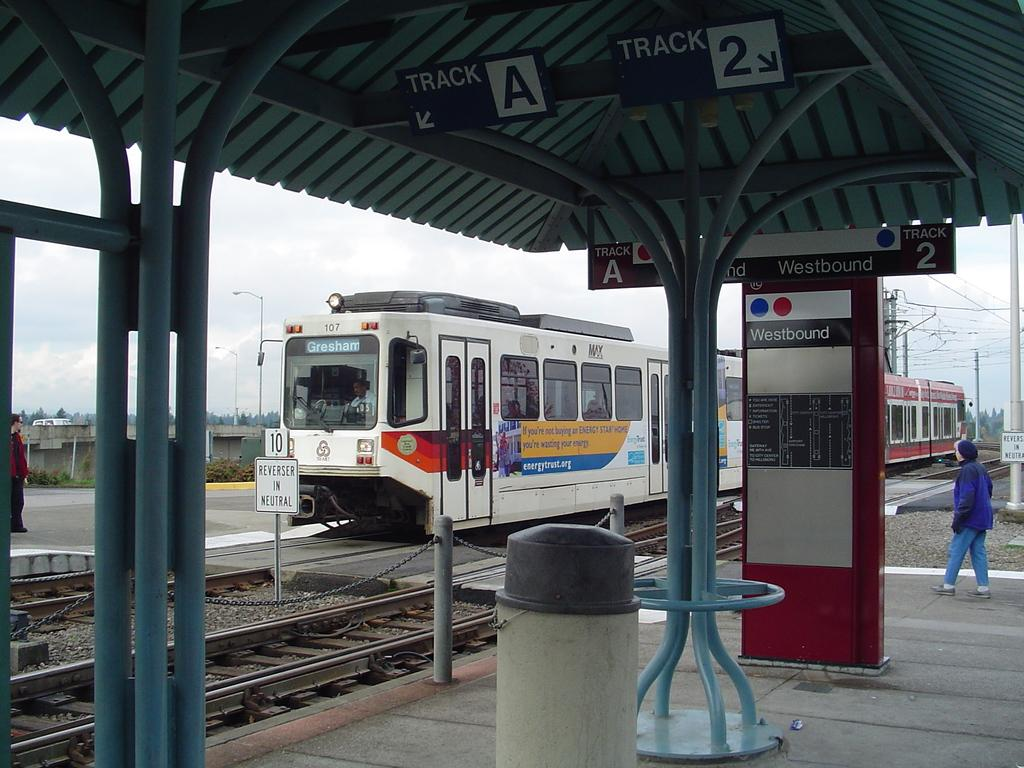<image>
Give a short and clear explanation of the subsequent image. A largely white train and the sign Westbound on a wall. 